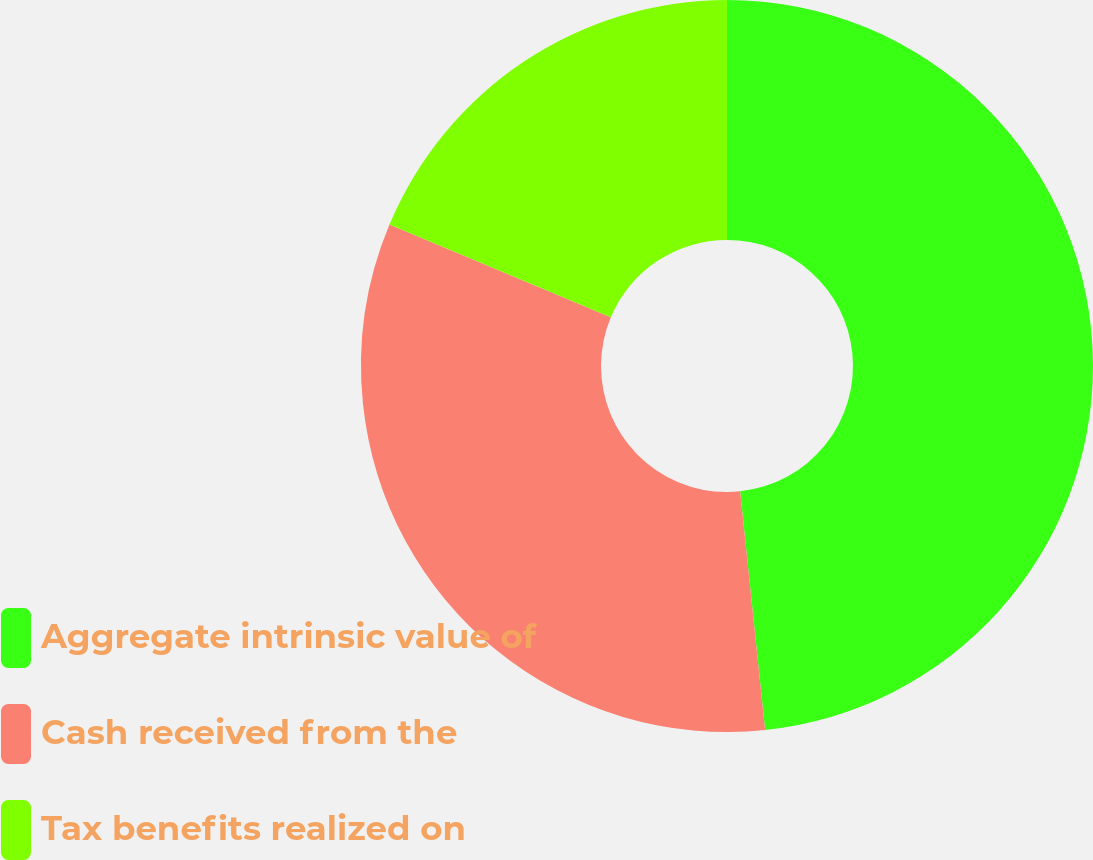Convert chart. <chart><loc_0><loc_0><loc_500><loc_500><pie_chart><fcel>Aggregate intrinsic value of<fcel>Cash received from the<fcel>Tax benefits realized on<nl><fcel>48.34%<fcel>32.98%<fcel>18.68%<nl></chart> 